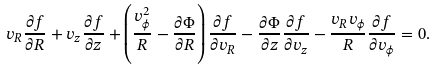<formula> <loc_0><loc_0><loc_500><loc_500>v _ { R } \frac { \partial f } { \partial R } + v _ { z } \frac { \partial f } { \partial z } + \left ( \frac { v _ { \phi } ^ { 2 } } { R } - \frac { \partial \Phi } { \partial R } \right ) \frac { \partial f } { \partial v _ { R } } - \frac { \partial \Phi } { \partial z } \frac { \partial f } { \partial v _ { z } } - \frac { v _ { R } v _ { \phi } } { R } \frac { \partial f } { \partial v _ { \phi } } = 0 .</formula> 